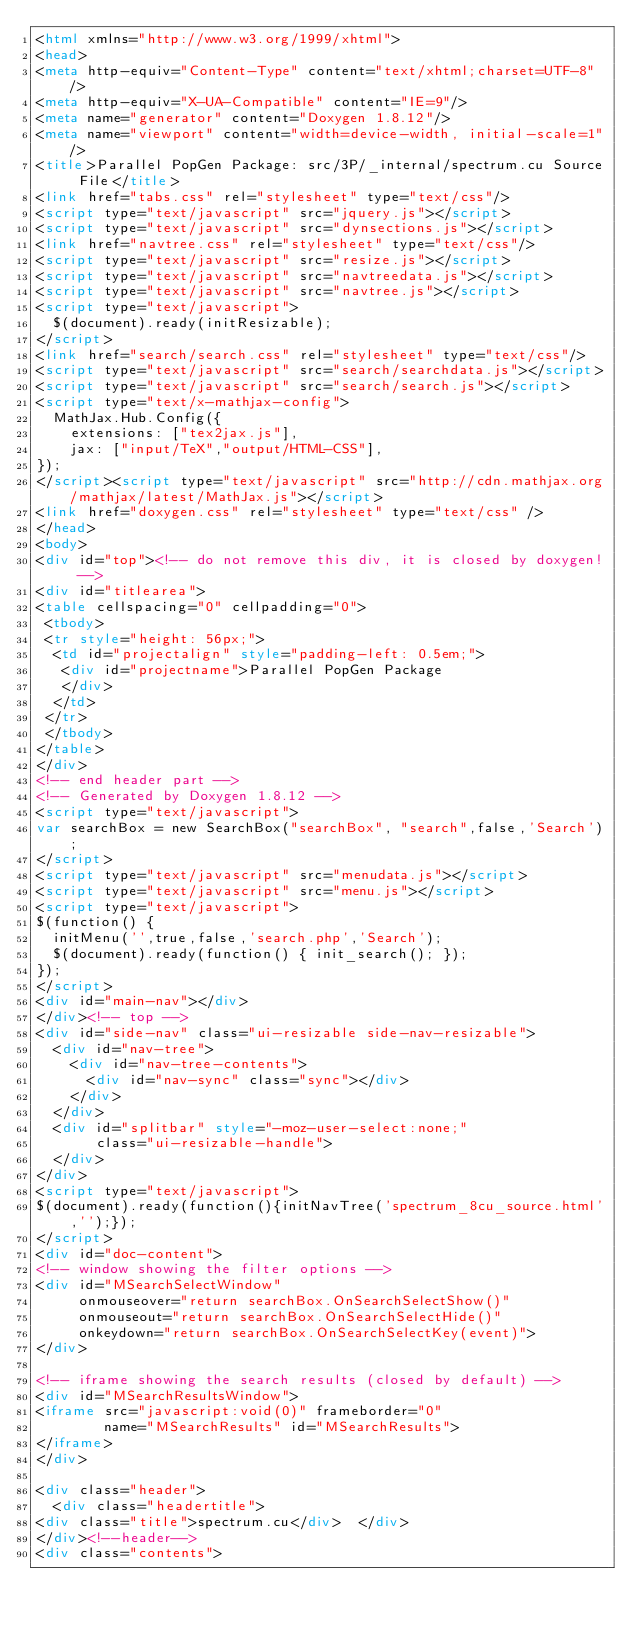Convert code to text. <code><loc_0><loc_0><loc_500><loc_500><_HTML_><html xmlns="http://www.w3.org/1999/xhtml">
<head>
<meta http-equiv="Content-Type" content="text/xhtml;charset=UTF-8"/>
<meta http-equiv="X-UA-Compatible" content="IE=9"/>
<meta name="generator" content="Doxygen 1.8.12"/>
<meta name="viewport" content="width=device-width, initial-scale=1"/>
<title>Parallel PopGen Package: src/3P/_internal/spectrum.cu Source File</title>
<link href="tabs.css" rel="stylesheet" type="text/css"/>
<script type="text/javascript" src="jquery.js"></script>
<script type="text/javascript" src="dynsections.js"></script>
<link href="navtree.css" rel="stylesheet" type="text/css"/>
<script type="text/javascript" src="resize.js"></script>
<script type="text/javascript" src="navtreedata.js"></script>
<script type="text/javascript" src="navtree.js"></script>
<script type="text/javascript">
  $(document).ready(initResizable);
</script>
<link href="search/search.css" rel="stylesheet" type="text/css"/>
<script type="text/javascript" src="search/searchdata.js"></script>
<script type="text/javascript" src="search/search.js"></script>
<script type="text/x-mathjax-config">
  MathJax.Hub.Config({
    extensions: ["tex2jax.js"],
    jax: ["input/TeX","output/HTML-CSS"],
});
</script><script type="text/javascript" src="http://cdn.mathjax.org/mathjax/latest/MathJax.js"></script>
<link href="doxygen.css" rel="stylesheet" type="text/css" />
</head>
<body>
<div id="top"><!-- do not remove this div, it is closed by doxygen! -->
<div id="titlearea">
<table cellspacing="0" cellpadding="0">
 <tbody>
 <tr style="height: 56px;">
  <td id="projectalign" style="padding-left: 0.5em;">
   <div id="projectname">Parallel PopGen Package
   </div>
  </td>
 </tr>
 </tbody>
</table>
</div>
<!-- end header part -->
<!-- Generated by Doxygen 1.8.12 -->
<script type="text/javascript">
var searchBox = new SearchBox("searchBox", "search",false,'Search');
</script>
<script type="text/javascript" src="menudata.js"></script>
<script type="text/javascript" src="menu.js"></script>
<script type="text/javascript">
$(function() {
  initMenu('',true,false,'search.php','Search');
  $(document).ready(function() { init_search(); });
});
</script>
<div id="main-nav"></div>
</div><!-- top -->
<div id="side-nav" class="ui-resizable side-nav-resizable">
  <div id="nav-tree">
    <div id="nav-tree-contents">
      <div id="nav-sync" class="sync"></div>
    </div>
  </div>
  <div id="splitbar" style="-moz-user-select:none;" 
       class="ui-resizable-handle">
  </div>
</div>
<script type="text/javascript">
$(document).ready(function(){initNavTree('spectrum_8cu_source.html','');});
</script>
<div id="doc-content">
<!-- window showing the filter options -->
<div id="MSearchSelectWindow"
     onmouseover="return searchBox.OnSearchSelectShow()"
     onmouseout="return searchBox.OnSearchSelectHide()"
     onkeydown="return searchBox.OnSearchSelectKey(event)">
</div>

<!-- iframe showing the search results (closed by default) -->
<div id="MSearchResultsWindow">
<iframe src="javascript:void(0)" frameborder="0" 
        name="MSearchResults" id="MSearchResults">
</iframe>
</div>

<div class="header">
  <div class="headertitle">
<div class="title">spectrum.cu</div>  </div>
</div><!--header-->
<div class="contents"></code> 